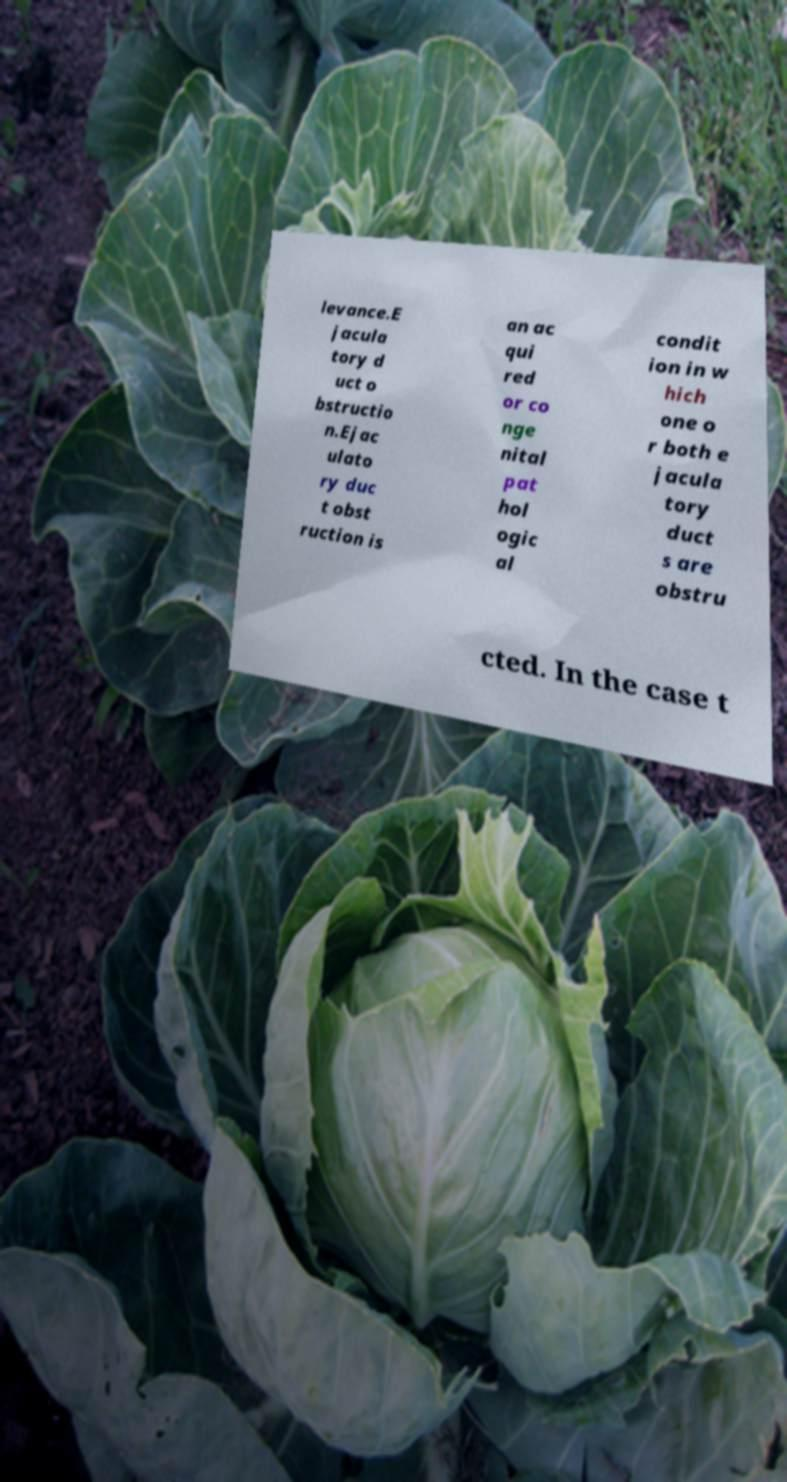Can you accurately transcribe the text from the provided image for me? levance.E jacula tory d uct o bstructio n.Ejac ulato ry duc t obst ruction is an ac qui red or co nge nital pat hol ogic al condit ion in w hich one o r both e jacula tory duct s are obstru cted. In the case t 